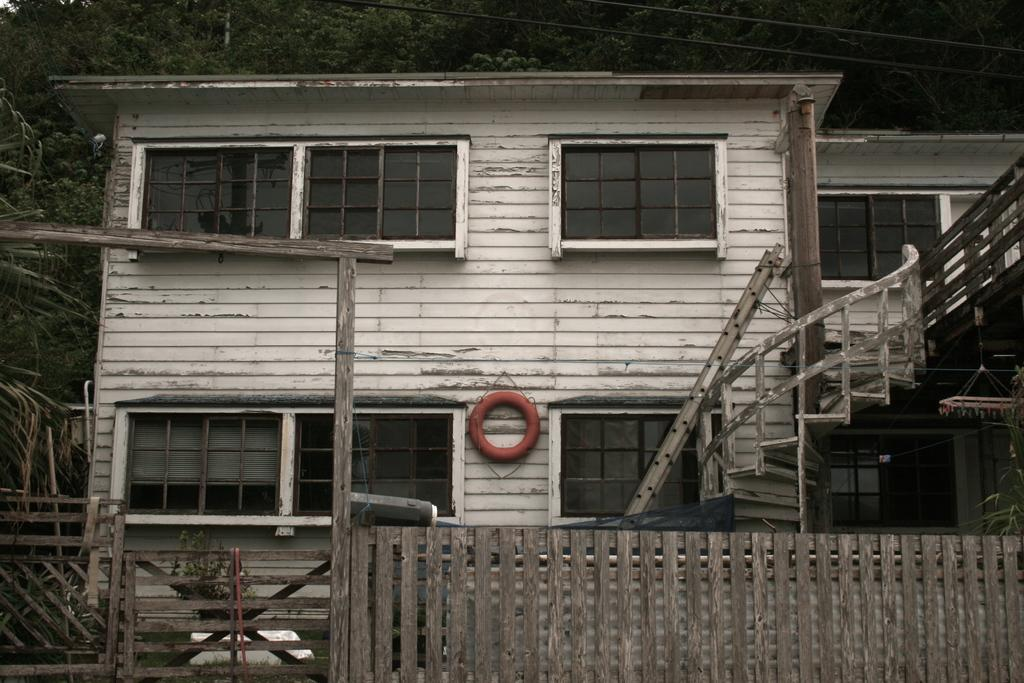What type of structures can be seen in the image? There are buildings in the image. What architectural feature is present in the buildings? There are windows in the image. Are there any access points to different levels in the buildings? Yes, there are stairs in the image. What type of vegetation is visible in the image? There are trees in the image. What time does the clock on the queen's necklace show in the image? There is no clock or queen present in the image; it features buildings, windows, stairs, and trees. 